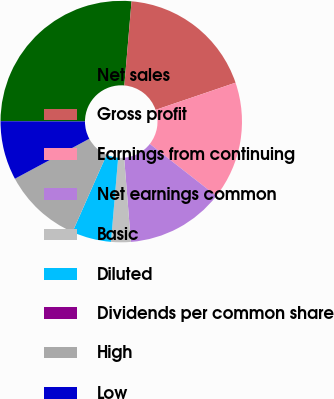Convert chart. <chart><loc_0><loc_0><loc_500><loc_500><pie_chart><fcel>Net sales<fcel>Gross profit<fcel>Earnings from continuing<fcel>Net earnings common<fcel>Basic<fcel>Diluted<fcel>Dividends per common share<fcel>High<fcel>Low<nl><fcel>26.31%<fcel>18.42%<fcel>15.79%<fcel>13.16%<fcel>2.63%<fcel>5.26%<fcel>0.0%<fcel>10.53%<fcel>7.9%<nl></chart> 